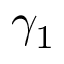<formula> <loc_0><loc_0><loc_500><loc_500>\gamma _ { 1 }</formula> 